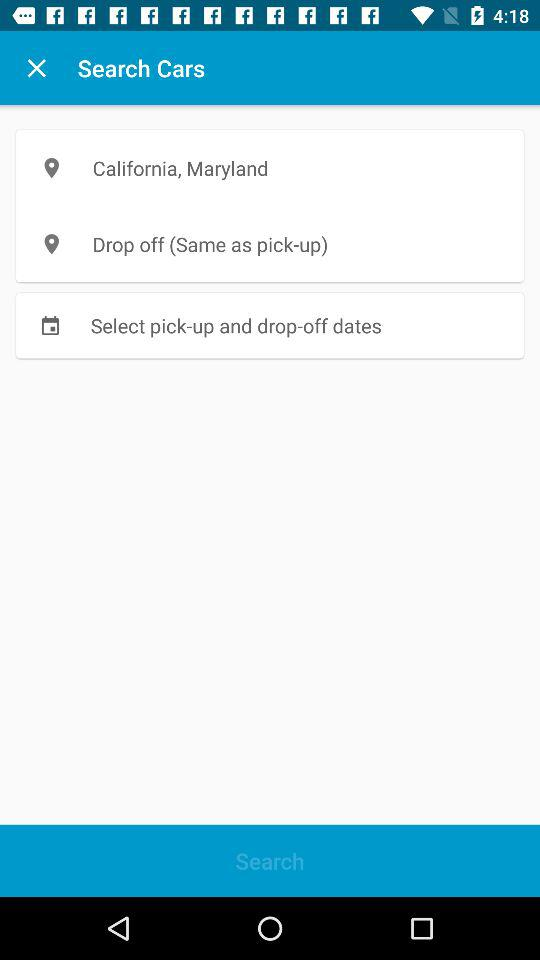What is the location for pick-up? The location for pick-up is California, Maryland. 